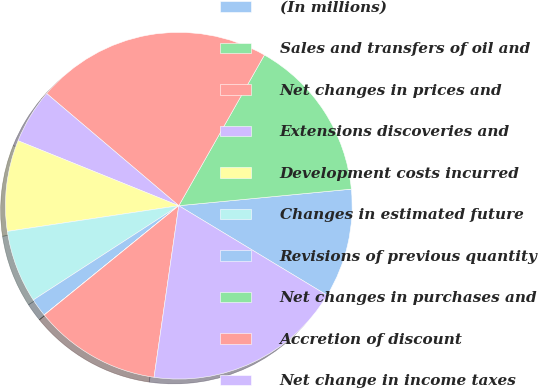Convert chart. <chart><loc_0><loc_0><loc_500><loc_500><pie_chart><fcel>(In millions)<fcel>Sales and transfers of oil and<fcel>Net changes in prices and<fcel>Extensions discoveries and<fcel>Development costs incurred<fcel>Changes in estimated future<fcel>Revisions of previous quantity<fcel>Net changes in purchases and<fcel>Accretion of discount<fcel>Net change in income taxes<nl><fcel>10.17%<fcel>15.25%<fcel>22.02%<fcel>5.09%<fcel>8.48%<fcel>6.78%<fcel>1.7%<fcel>0.01%<fcel>11.86%<fcel>18.63%<nl></chart> 